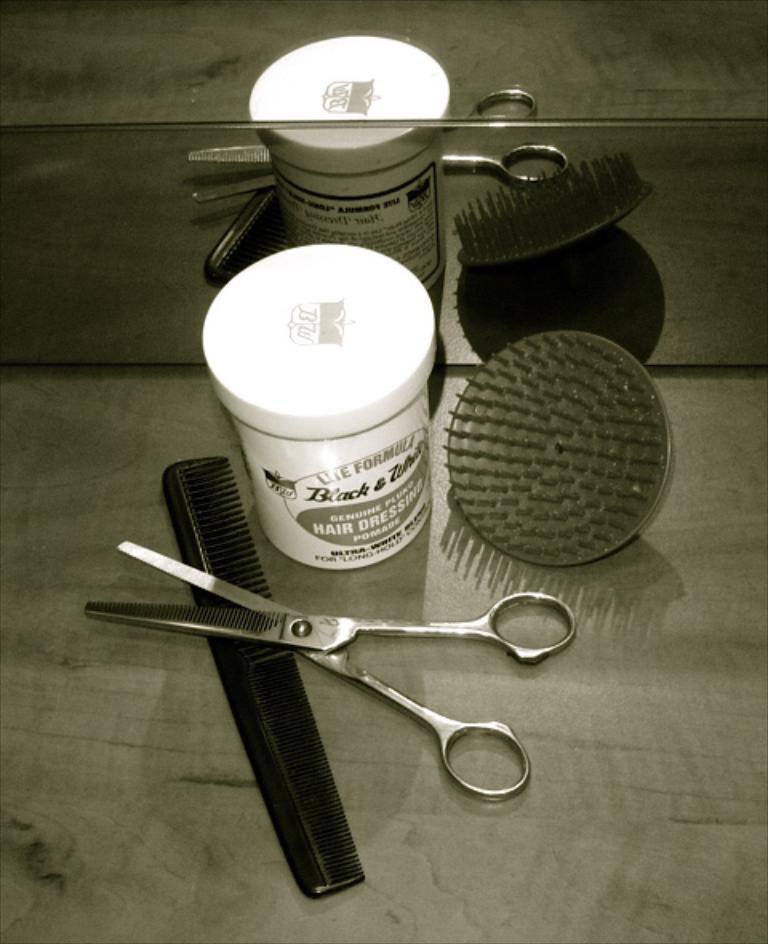Describe this image in one or two sentences. In this picture we can observe a small plastic bottle, comb and scissor placed on the table in front of a mirror. The small plastic bottle is in white color and the comb is in grey color. 